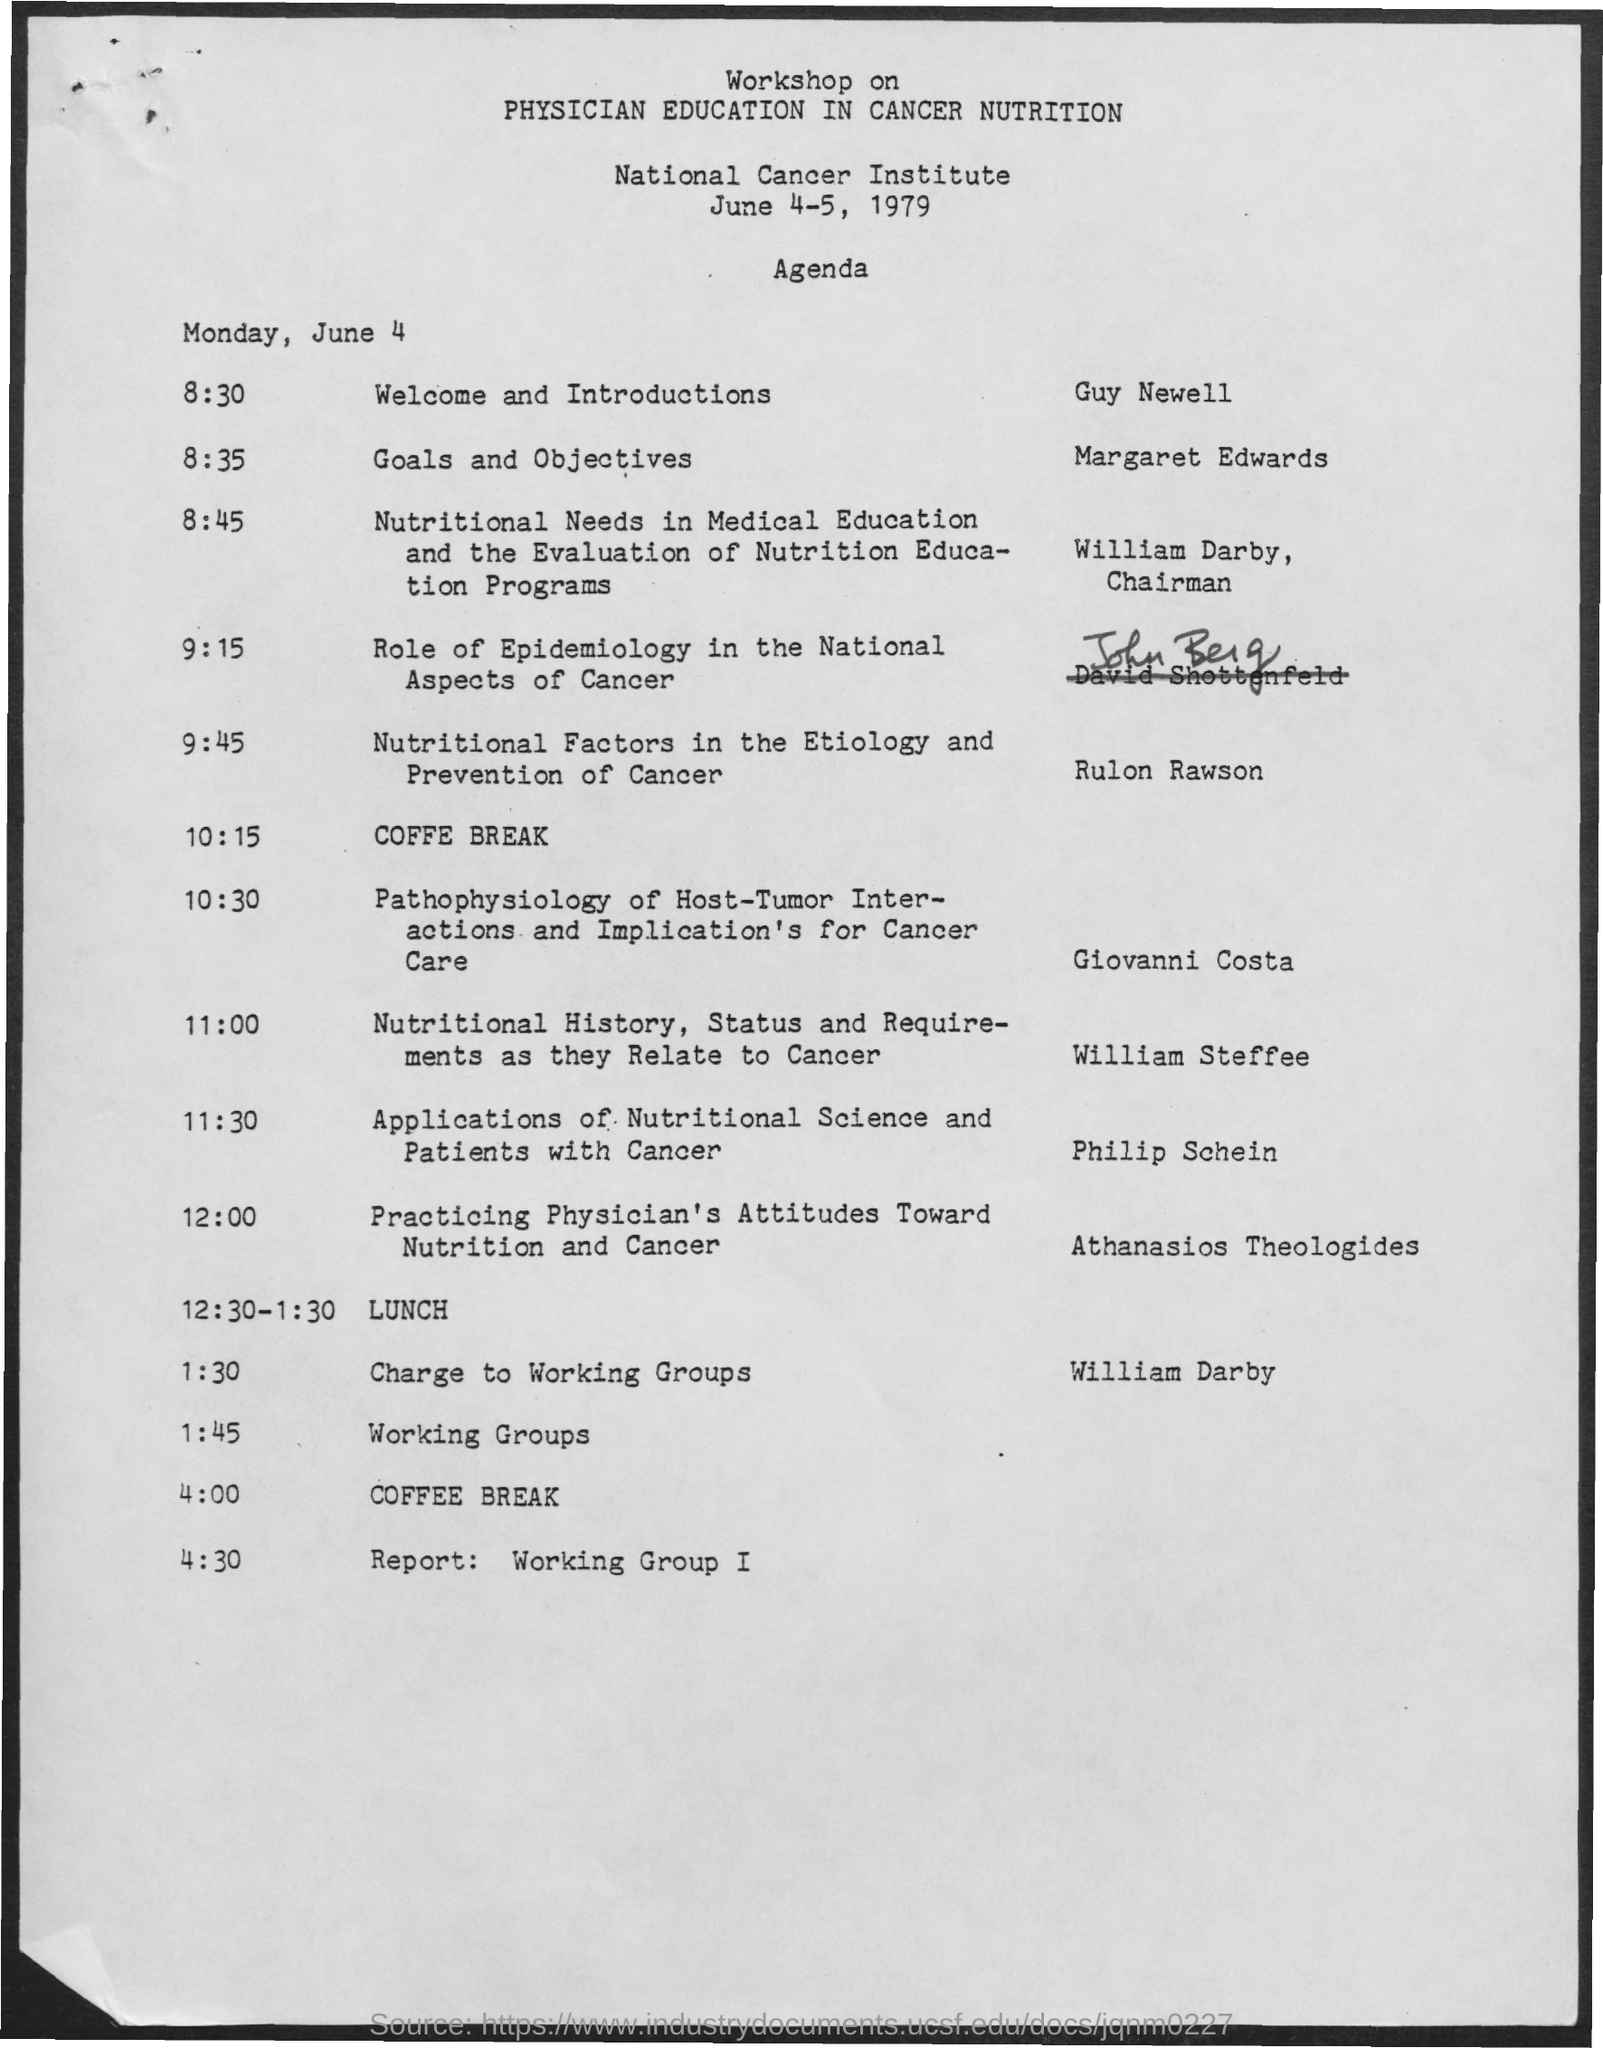Give some essential details in this illustration. After lunch, a workshop on the specified topic will take place and the cost will be charged to the designated working groups. William Darby is the chairman. After the lunch, William Darby will conduct the workshop. 